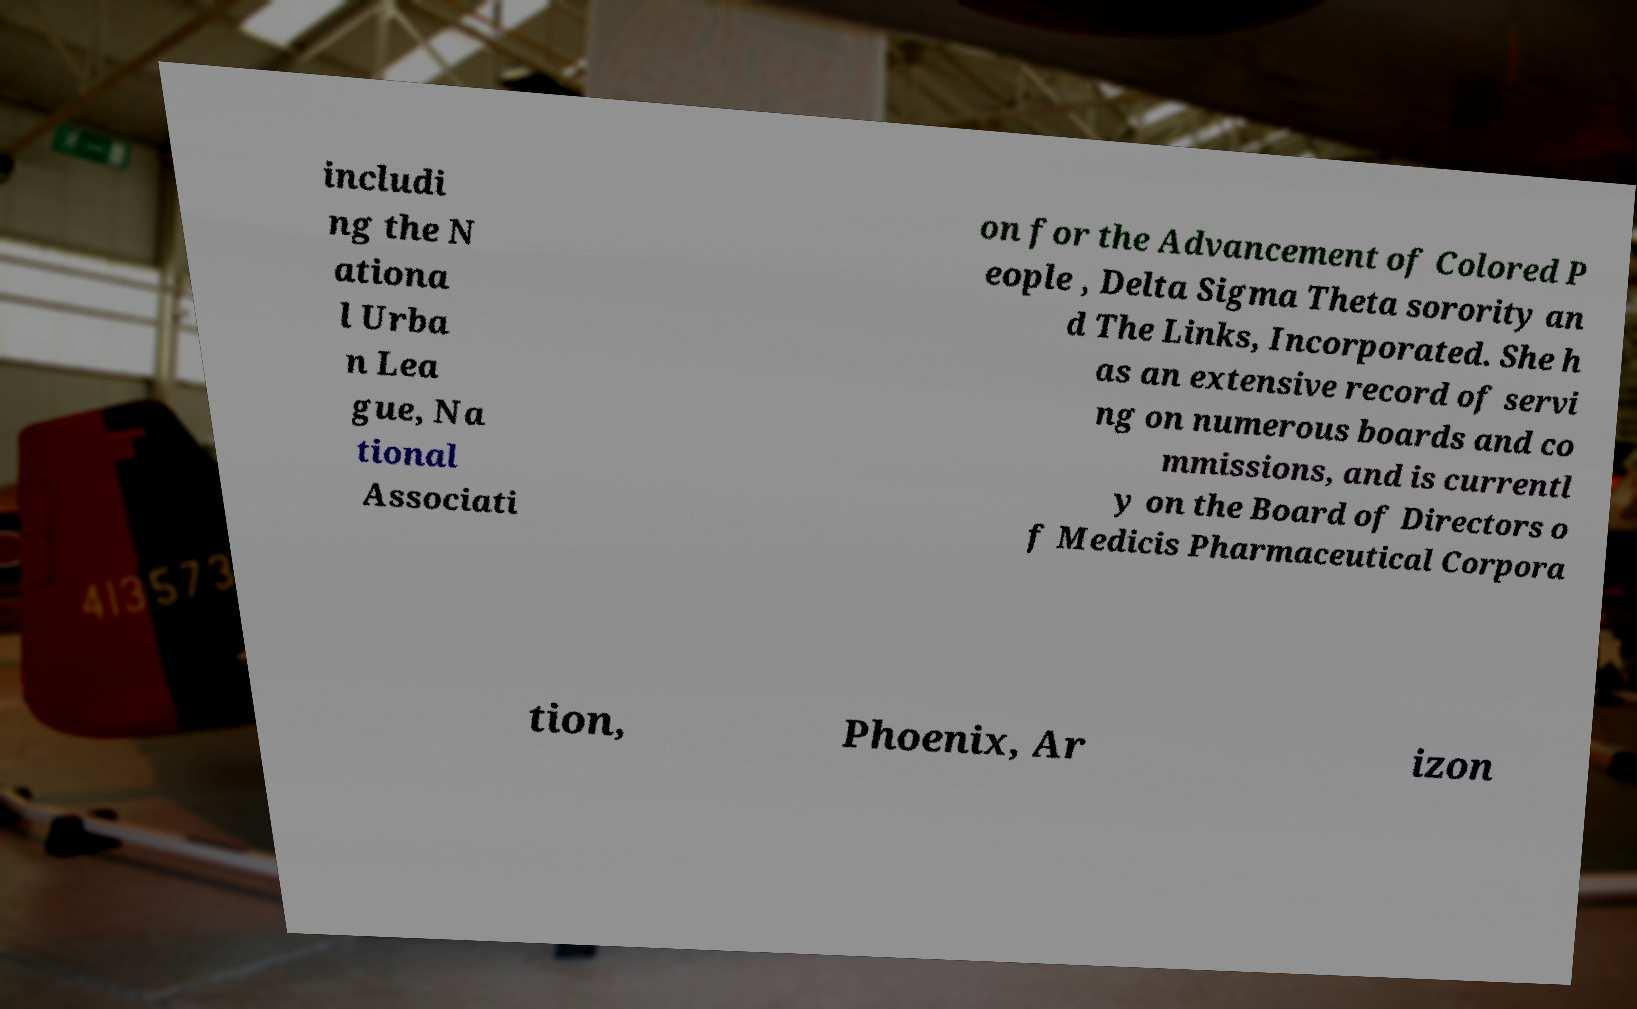Can you read and provide the text displayed in the image?This photo seems to have some interesting text. Can you extract and type it out for me? includi ng the N ationa l Urba n Lea gue, Na tional Associati on for the Advancement of Colored P eople , Delta Sigma Theta sorority an d The Links, Incorporated. She h as an extensive record of servi ng on numerous boards and co mmissions, and is currentl y on the Board of Directors o f Medicis Pharmaceutical Corpora tion, Phoenix, Ar izon 